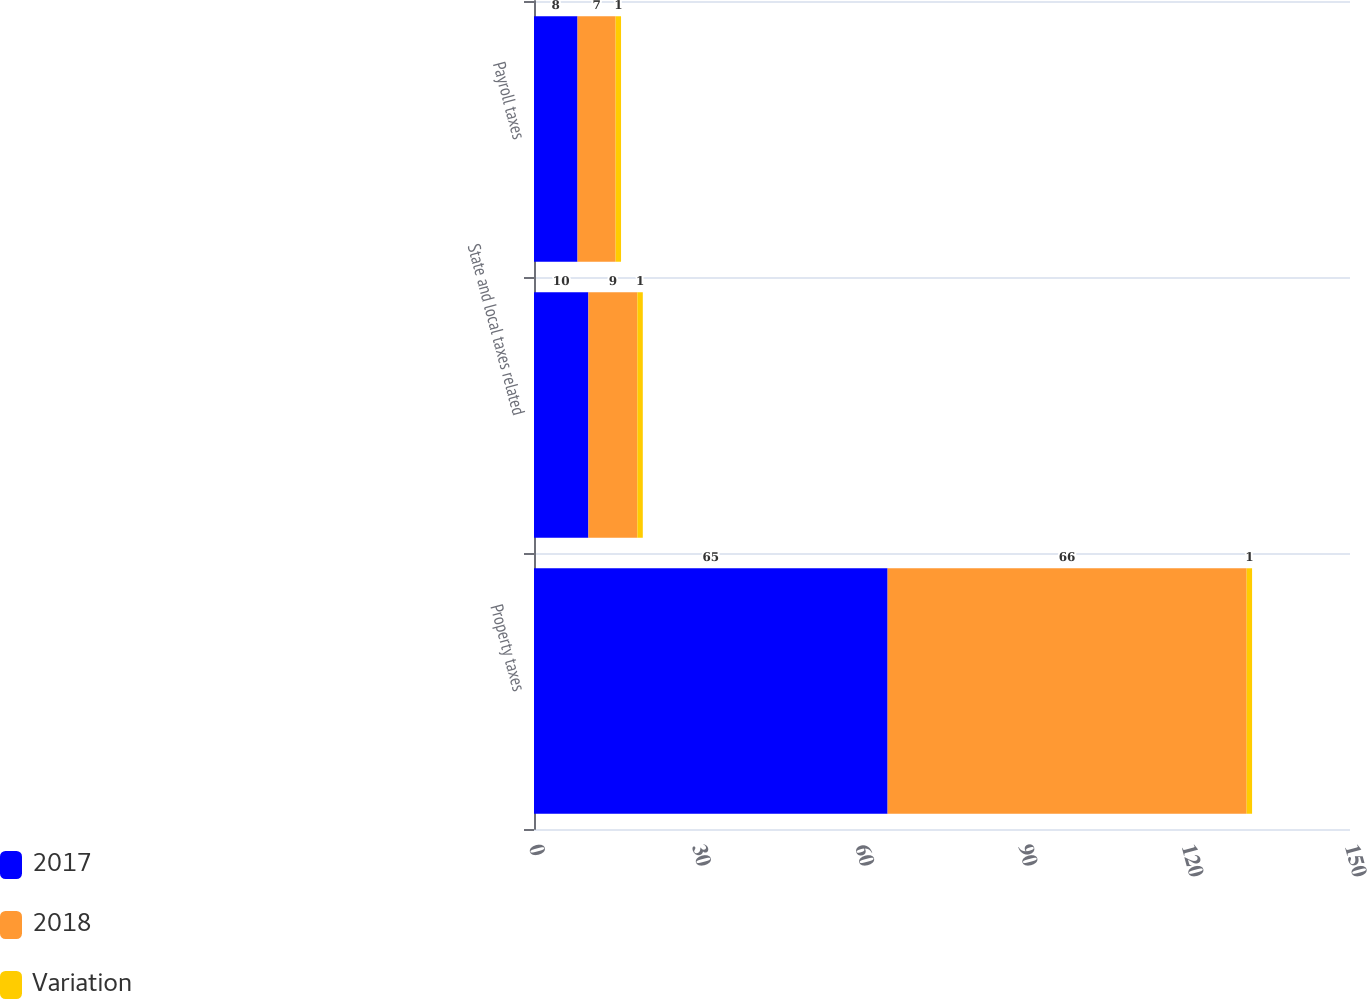<chart> <loc_0><loc_0><loc_500><loc_500><stacked_bar_chart><ecel><fcel>Property taxes<fcel>State and local taxes related<fcel>Payroll taxes<nl><fcel>2017<fcel>65<fcel>10<fcel>8<nl><fcel>2018<fcel>66<fcel>9<fcel>7<nl><fcel>Variation<fcel>1<fcel>1<fcel>1<nl></chart> 